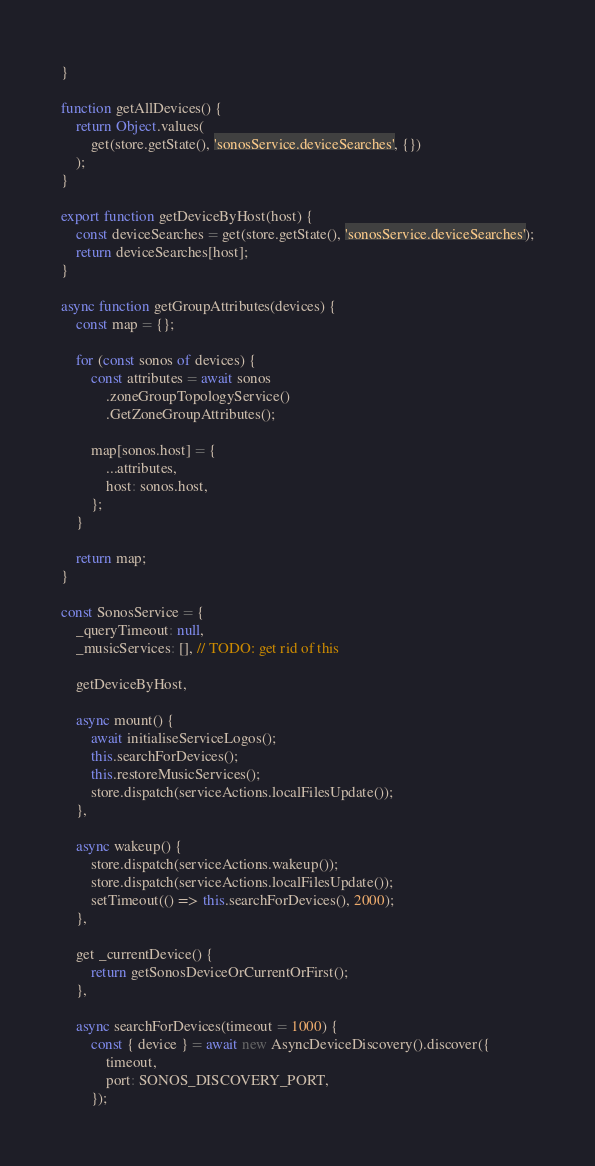<code> <loc_0><loc_0><loc_500><loc_500><_JavaScript_>}

function getAllDevices() {
    return Object.values(
        get(store.getState(), 'sonosService.deviceSearches', {})
    );
}

export function getDeviceByHost(host) {
    const deviceSearches = get(store.getState(), 'sonosService.deviceSearches');
    return deviceSearches[host];
}

async function getGroupAttributes(devices) {
    const map = {};

    for (const sonos of devices) {
        const attributes = await sonos
            .zoneGroupTopologyService()
            .GetZoneGroupAttributes();

        map[sonos.host] = {
            ...attributes,
            host: sonos.host,
        };
    }

    return map;
}

const SonosService = {
    _queryTimeout: null,
    _musicServices: [], // TODO: get rid of this

    getDeviceByHost,

    async mount() {
        await initialiseServiceLogos();
        this.searchForDevices();
        this.restoreMusicServices();
        store.dispatch(serviceActions.localFilesUpdate());
    },

    async wakeup() {
        store.dispatch(serviceActions.wakeup());
        store.dispatch(serviceActions.localFilesUpdate());
        setTimeout(() => this.searchForDevices(), 2000);
    },

    get _currentDevice() {
        return getSonosDeviceOrCurrentOrFirst();
    },

    async searchForDevices(timeout = 1000) {
        const { device } = await new AsyncDeviceDiscovery().discover({
            timeout,
            port: SONOS_DISCOVERY_PORT,
        });</code> 